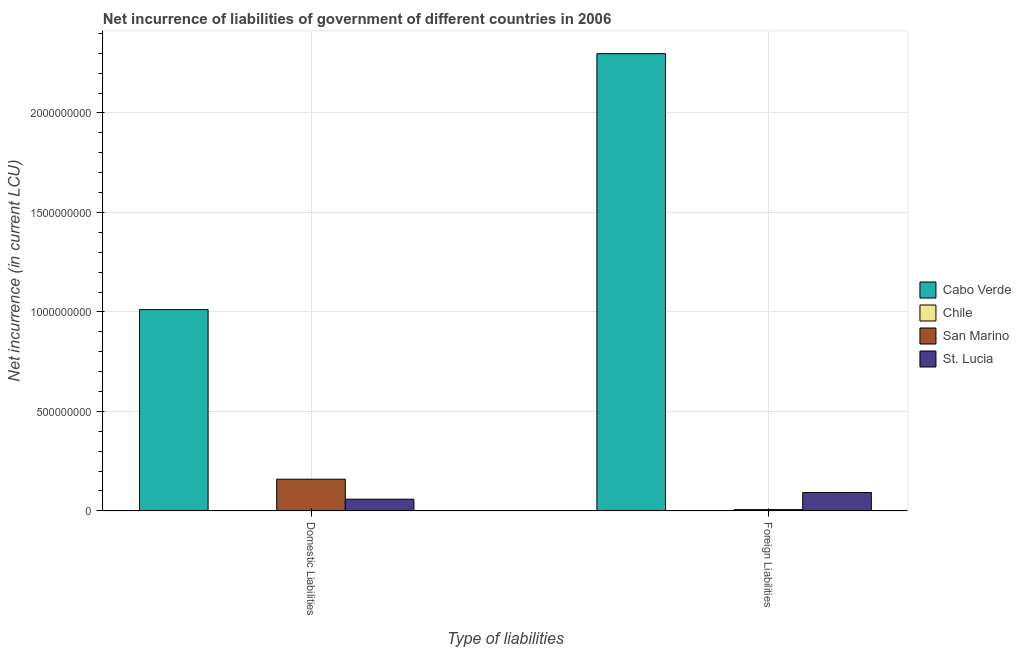How many different coloured bars are there?
Offer a very short reply. 3. How many groups of bars are there?
Your response must be concise. 2. How many bars are there on the 2nd tick from the left?
Provide a short and direct response. 3. What is the label of the 2nd group of bars from the left?
Offer a very short reply. Foreign Liabilities. What is the net incurrence of foreign liabilities in Cabo Verde?
Provide a short and direct response. 2.30e+09. Across all countries, what is the maximum net incurrence of foreign liabilities?
Your answer should be very brief. 2.30e+09. Across all countries, what is the minimum net incurrence of domestic liabilities?
Offer a very short reply. 0. In which country was the net incurrence of domestic liabilities maximum?
Provide a succinct answer. Cabo Verde. What is the total net incurrence of domestic liabilities in the graph?
Ensure brevity in your answer.  1.23e+09. What is the difference between the net incurrence of foreign liabilities in San Marino and that in St. Lucia?
Your response must be concise. -8.59e+07. What is the difference between the net incurrence of foreign liabilities in Cabo Verde and the net incurrence of domestic liabilities in Chile?
Offer a very short reply. 2.30e+09. What is the average net incurrence of domestic liabilities per country?
Provide a short and direct response. 3.07e+08. What is the difference between the net incurrence of domestic liabilities and net incurrence of foreign liabilities in Cabo Verde?
Ensure brevity in your answer.  -1.29e+09. What is the ratio of the net incurrence of domestic liabilities in Cabo Verde to that in San Marino?
Your answer should be very brief. 6.35. Is the net incurrence of foreign liabilities in St. Lucia less than that in Cabo Verde?
Your response must be concise. Yes. In how many countries, is the net incurrence of domestic liabilities greater than the average net incurrence of domestic liabilities taken over all countries?
Your answer should be very brief. 1. How many countries are there in the graph?
Your answer should be compact. 4. Does the graph contain any zero values?
Your answer should be compact. Yes. Does the graph contain grids?
Provide a succinct answer. Yes. Where does the legend appear in the graph?
Your answer should be very brief. Center right. How many legend labels are there?
Ensure brevity in your answer.  4. What is the title of the graph?
Provide a short and direct response. Net incurrence of liabilities of government of different countries in 2006. Does "South Asia" appear as one of the legend labels in the graph?
Ensure brevity in your answer.  No. What is the label or title of the X-axis?
Provide a short and direct response. Type of liabilities. What is the label or title of the Y-axis?
Give a very brief answer. Net incurrence (in current LCU). What is the Net incurrence (in current LCU) of Cabo Verde in Domestic Liabilities?
Provide a succinct answer. 1.01e+09. What is the Net incurrence (in current LCU) in Chile in Domestic Liabilities?
Offer a very short reply. 0. What is the Net incurrence (in current LCU) in San Marino in Domestic Liabilities?
Provide a succinct answer. 1.59e+08. What is the Net incurrence (in current LCU) of St. Lucia in Domestic Liabilities?
Your answer should be compact. 5.87e+07. What is the Net incurrence (in current LCU) in Cabo Verde in Foreign Liabilities?
Offer a terse response. 2.30e+09. What is the Net incurrence (in current LCU) in Chile in Foreign Liabilities?
Provide a succinct answer. 0. What is the Net incurrence (in current LCU) of San Marino in Foreign Liabilities?
Your answer should be very brief. 6.37e+06. What is the Net incurrence (in current LCU) of St. Lucia in Foreign Liabilities?
Offer a terse response. 9.23e+07. Across all Type of liabilities, what is the maximum Net incurrence (in current LCU) in Cabo Verde?
Your answer should be very brief. 2.30e+09. Across all Type of liabilities, what is the maximum Net incurrence (in current LCU) of San Marino?
Give a very brief answer. 1.59e+08. Across all Type of liabilities, what is the maximum Net incurrence (in current LCU) of St. Lucia?
Ensure brevity in your answer.  9.23e+07. Across all Type of liabilities, what is the minimum Net incurrence (in current LCU) in Cabo Verde?
Provide a short and direct response. 1.01e+09. Across all Type of liabilities, what is the minimum Net incurrence (in current LCU) of San Marino?
Provide a short and direct response. 6.37e+06. Across all Type of liabilities, what is the minimum Net incurrence (in current LCU) in St. Lucia?
Ensure brevity in your answer.  5.87e+07. What is the total Net incurrence (in current LCU) of Cabo Verde in the graph?
Make the answer very short. 3.31e+09. What is the total Net incurrence (in current LCU) in San Marino in the graph?
Provide a short and direct response. 1.66e+08. What is the total Net incurrence (in current LCU) in St. Lucia in the graph?
Keep it short and to the point. 1.51e+08. What is the difference between the Net incurrence (in current LCU) of Cabo Verde in Domestic Liabilities and that in Foreign Liabilities?
Your answer should be compact. -1.29e+09. What is the difference between the Net incurrence (in current LCU) in San Marino in Domestic Liabilities and that in Foreign Liabilities?
Offer a very short reply. 1.53e+08. What is the difference between the Net incurrence (in current LCU) of St. Lucia in Domestic Liabilities and that in Foreign Liabilities?
Keep it short and to the point. -3.36e+07. What is the difference between the Net incurrence (in current LCU) in Cabo Verde in Domestic Liabilities and the Net incurrence (in current LCU) in San Marino in Foreign Liabilities?
Your answer should be compact. 1.01e+09. What is the difference between the Net incurrence (in current LCU) in Cabo Verde in Domestic Liabilities and the Net incurrence (in current LCU) in St. Lucia in Foreign Liabilities?
Offer a very short reply. 9.19e+08. What is the difference between the Net incurrence (in current LCU) in San Marino in Domestic Liabilities and the Net incurrence (in current LCU) in St. Lucia in Foreign Liabilities?
Provide a succinct answer. 6.70e+07. What is the average Net incurrence (in current LCU) of Cabo Verde per Type of liabilities?
Your answer should be compact. 1.65e+09. What is the average Net incurrence (in current LCU) of San Marino per Type of liabilities?
Your answer should be compact. 8.28e+07. What is the average Net incurrence (in current LCU) in St. Lucia per Type of liabilities?
Make the answer very short. 7.55e+07. What is the difference between the Net incurrence (in current LCU) of Cabo Verde and Net incurrence (in current LCU) of San Marino in Domestic Liabilities?
Your answer should be very brief. 8.52e+08. What is the difference between the Net incurrence (in current LCU) in Cabo Verde and Net incurrence (in current LCU) in St. Lucia in Domestic Liabilities?
Give a very brief answer. 9.53e+08. What is the difference between the Net incurrence (in current LCU) in San Marino and Net incurrence (in current LCU) in St. Lucia in Domestic Liabilities?
Give a very brief answer. 1.01e+08. What is the difference between the Net incurrence (in current LCU) in Cabo Verde and Net incurrence (in current LCU) in San Marino in Foreign Liabilities?
Offer a terse response. 2.29e+09. What is the difference between the Net incurrence (in current LCU) in Cabo Verde and Net incurrence (in current LCU) in St. Lucia in Foreign Liabilities?
Give a very brief answer. 2.21e+09. What is the difference between the Net incurrence (in current LCU) in San Marino and Net incurrence (in current LCU) in St. Lucia in Foreign Liabilities?
Your answer should be very brief. -8.59e+07. What is the ratio of the Net incurrence (in current LCU) in Cabo Verde in Domestic Liabilities to that in Foreign Liabilities?
Your answer should be very brief. 0.44. What is the ratio of the Net incurrence (in current LCU) in San Marino in Domestic Liabilities to that in Foreign Liabilities?
Your response must be concise. 24.99. What is the ratio of the Net incurrence (in current LCU) in St. Lucia in Domestic Liabilities to that in Foreign Liabilities?
Keep it short and to the point. 0.64. What is the difference between the highest and the second highest Net incurrence (in current LCU) of Cabo Verde?
Your response must be concise. 1.29e+09. What is the difference between the highest and the second highest Net incurrence (in current LCU) of San Marino?
Your response must be concise. 1.53e+08. What is the difference between the highest and the second highest Net incurrence (in current LCU) in St. Lucia?
Offer a terse response. 3.36e+07. What is the difference between the highest and the lowest Net incurrence (in current LCU) in Cabo Verde?
Your answer should be compact. 1.29e+09. What is the difference between the highest and the lowest Net incurrence (in current LCU) of San Marino?
Keep it short and to the point. 1.53e+08. What is the difference between the highest and the lowest Net incurrence (in current LCU) in St. Lucia?
Your answer should be compact. 3.36e+07. 